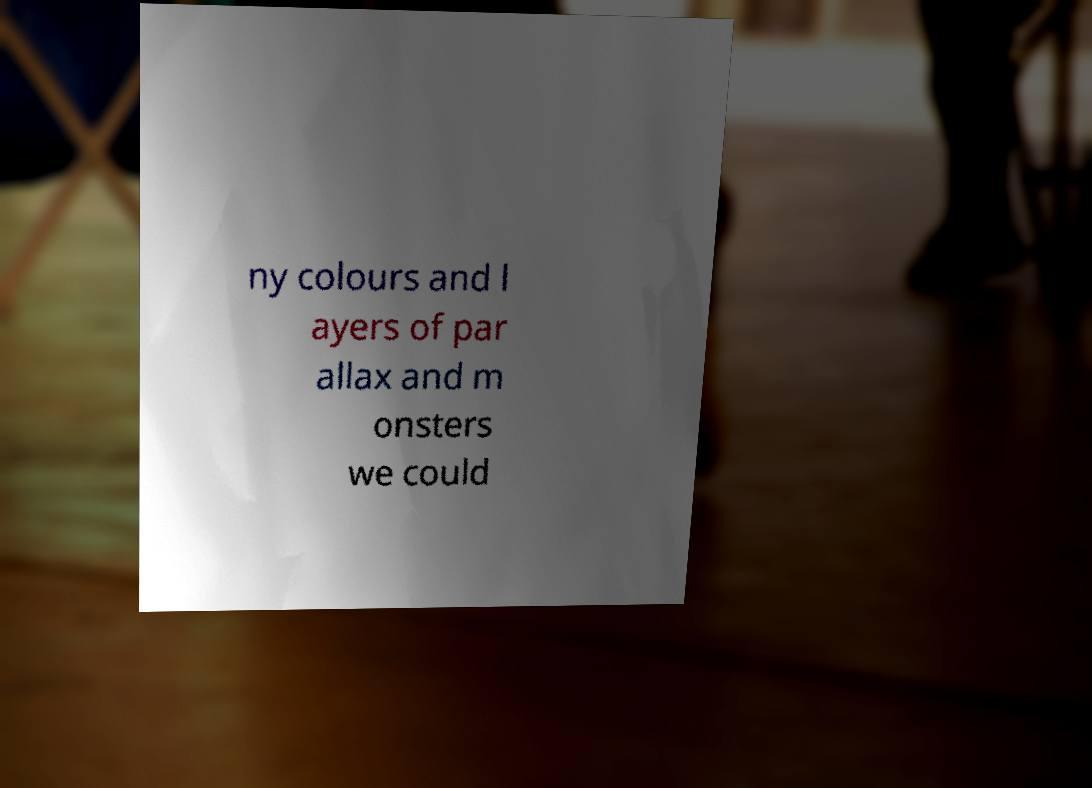Could you extract and type out the text from this image? ny colours and l ayers of par allax and m onsters we could 